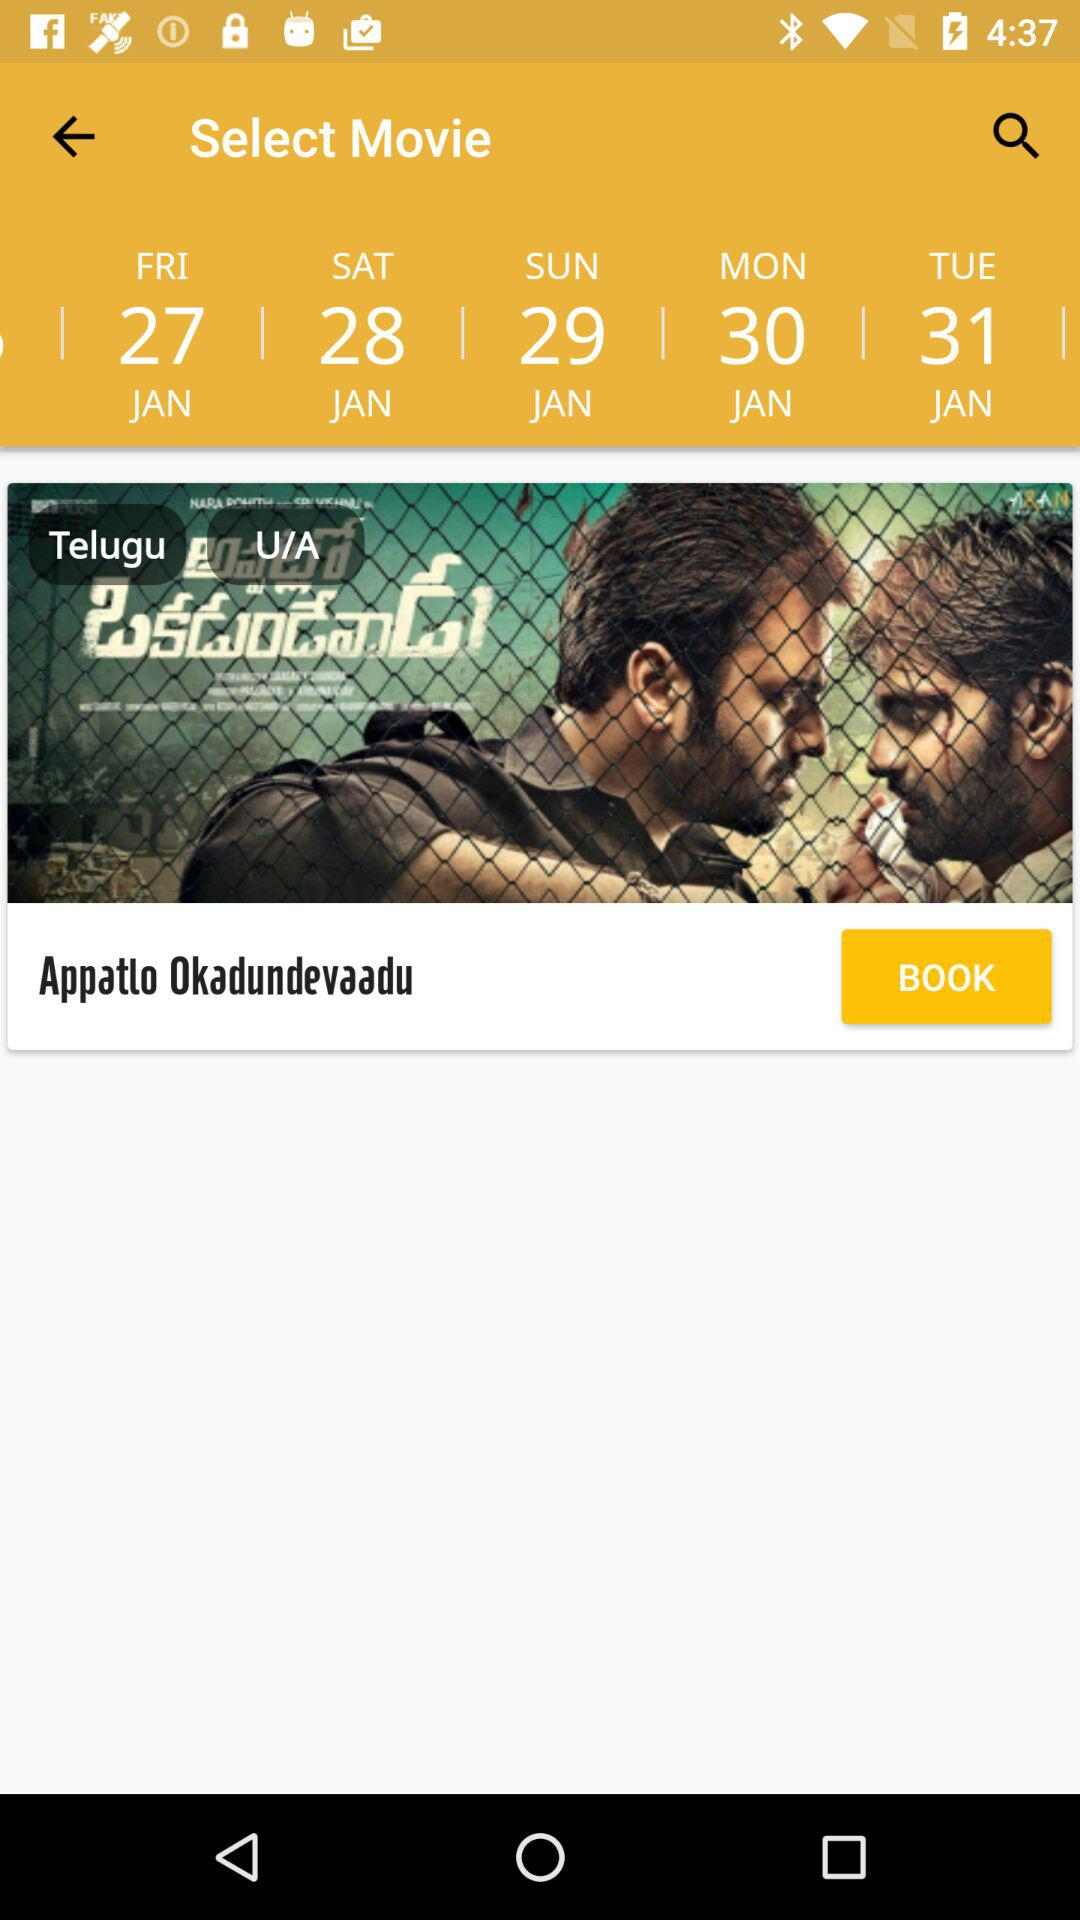What is the mentioned month? The mentioned month is January. 